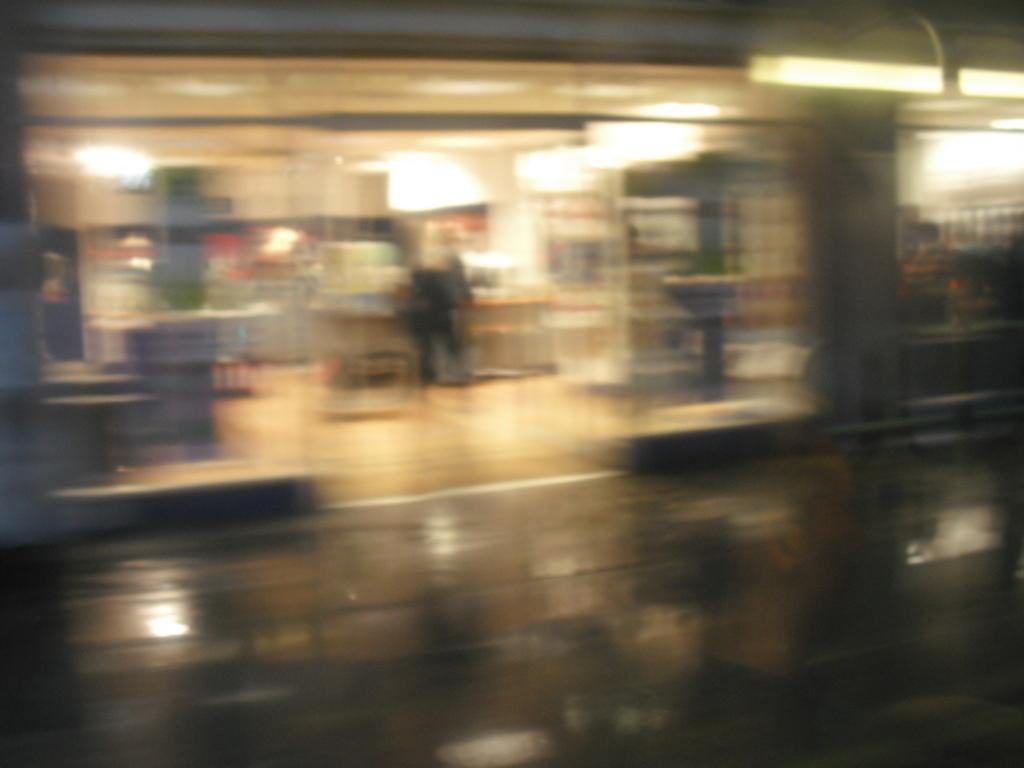What can be seen in the image that provides illumination? There is a light in the image. Can you describe the background of the image? The background of the image is blurry. What type of meal is being exchanged in the image? There is no meal or exchange present in the image; it only features a light and a blurry background. 